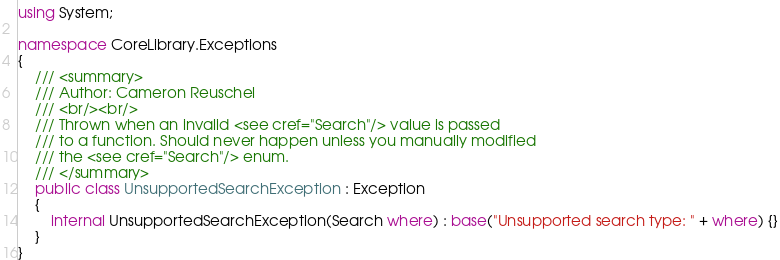Convert code to text. <code><loc_0><loc_0><loc_500><loc_500><_C#_>using System;

namespace CoreLibrary.Exceptions
{
    /// <summary>
    /// Author: Cameron Reuschel
    /// <br/><br/>
    /// Thrown when an invalid <see cref="Search"/> value is passed
    /// to a function. Should never happen unless you manually modified
    /// the <see cref="Search"/> enum.
    /// </summary>
    public class UnsupportedSearchException : Exception
    {
        internal UnsupportedSearchException(Search where) : base("Unsupported search type: " + where) {}
    }
}</code> 